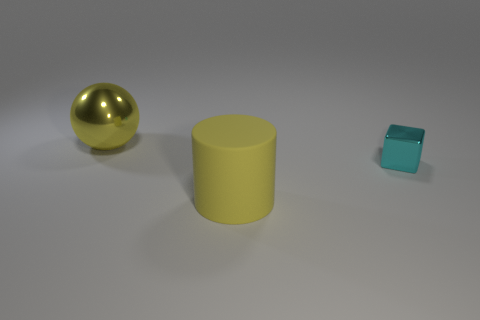There is a object that is the same color as the big cylinder; what material is it? The small object that shares the same color as the large cylinder appears to be made of a translucent material, possibly glass or acrylic, given its clarity and the way light interacts with it. 